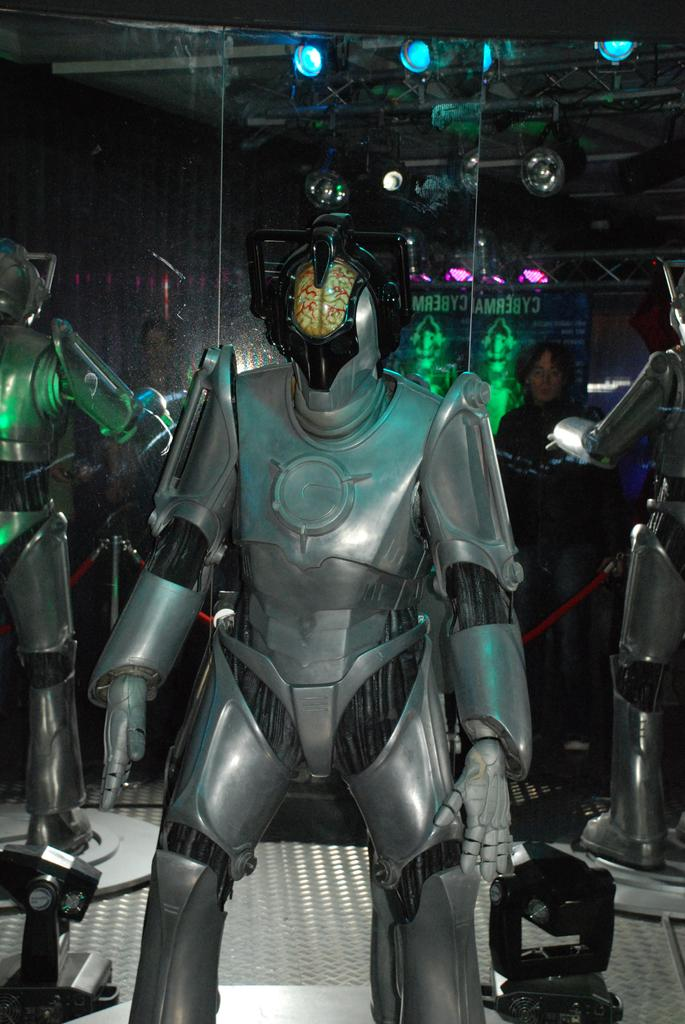What objects are placed on the surface in the image? There are robots placed on a surface in the image. What feature can be seen on the robots in the image? There are lights visible on the backside of the robots in the image. Can you describe the presence of a person in the image? There is a person standing in the image. What is the nature of the reflections in the image? Reflections are present on the glass in the image. What type of cows can be seen grazing in the background of the image? There are no cows present in the image; it features robots on a surface with lights and a person standing nearby. 